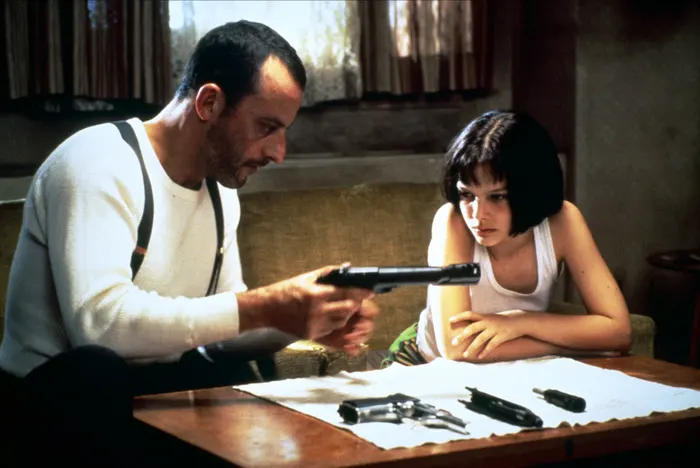What do you think the piece of paper on the table signifies? The piece of paper on the table could be a crucial element, possibly containing information related to their next mission, a target, or tactical details for an upcoming task. It might also hold personal significance, such as a plan for escape or a list of important things Mathilda needs to learn. In the context of their relationship and the narrative, it signifies something that both characters are deeply invested in—representing their shared purpose and the meticulous preparation required for their survival. Create a surreal scenario based on the image. Imagine that, as Léon and Mathilda study the piece of paper, the ink begins to swirl and morph into a living map that projects their path into a labyrinthine city. Each step they take in the room materializes on the map, altering the structure of buildings and streets in real-time. Suddenly, they hear whispers emanating from the map, giving cryptic hints about hidden dangers and secret passages. The room transforms around them, becoming a blend of reality and the map's projections. Their mission now involves deciphering these ethereal clues to navigate through this ever-shifting urban maze to find a hidden sanctuary that promises safety and answers to their deepest questions. 